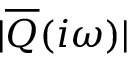Convert formula to latex. <formula><loc_0><loc_0><loc_500><loc_500>| \overline { Q } ( i \omega ) |</formula> 